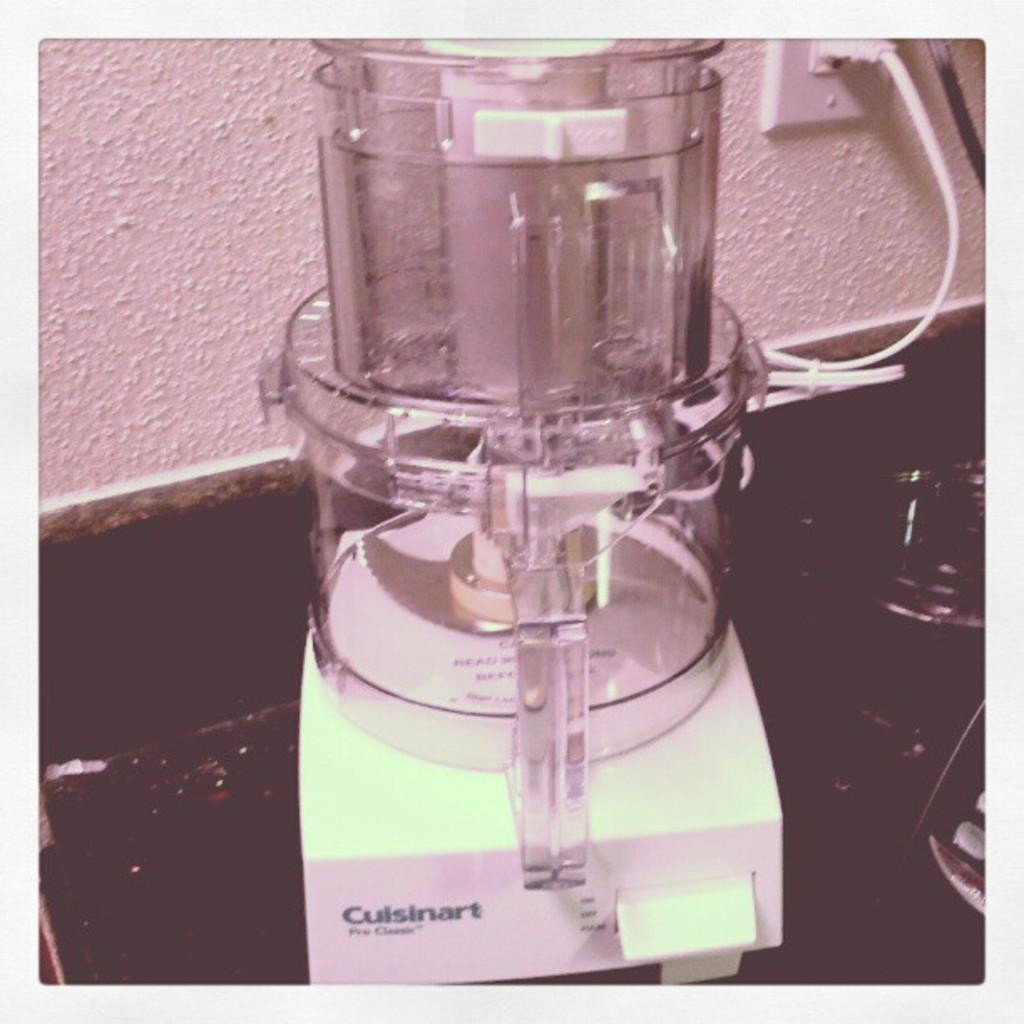<image>
Write a terse but informative summary of the picture. a blender that has the word Cuisinart on it 